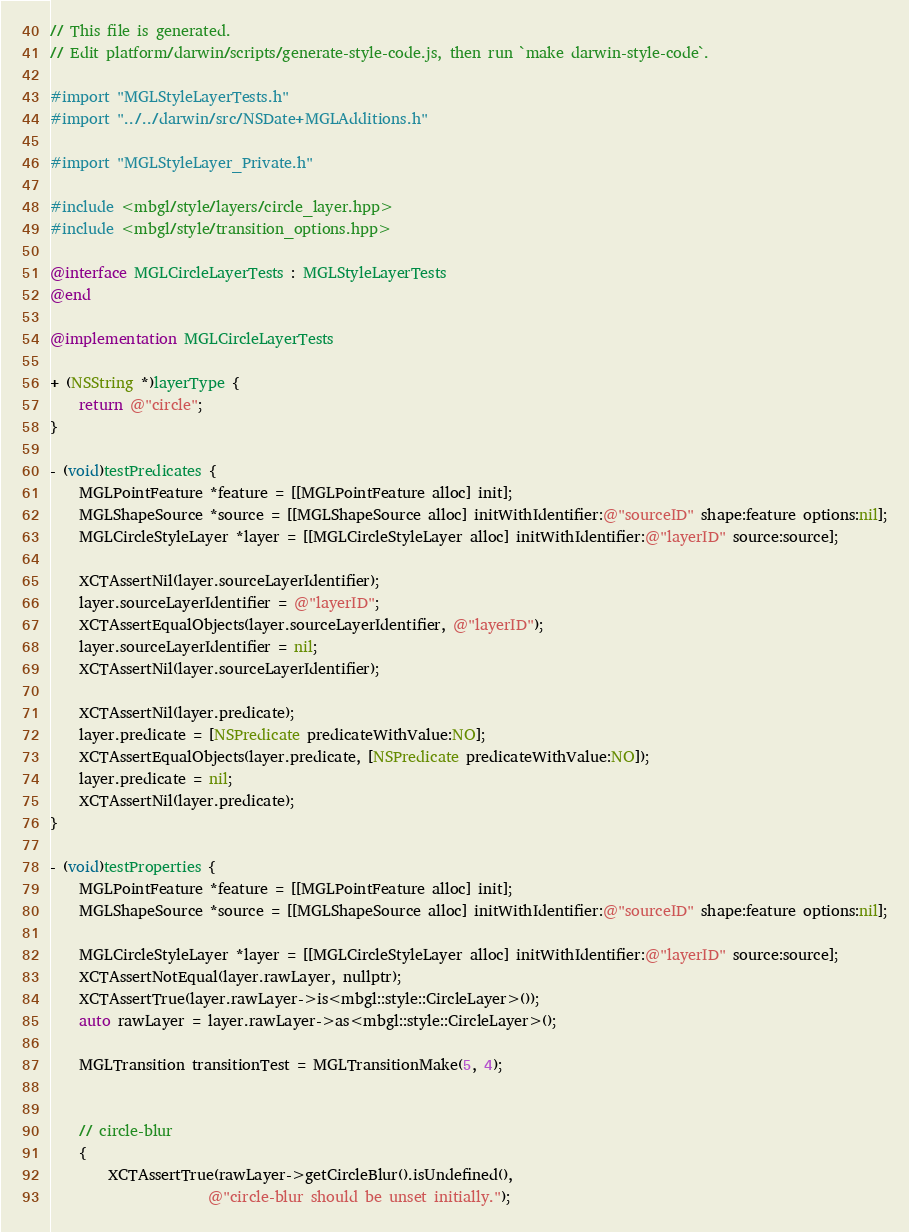<code> <loc_0><loc_0><loc_500><loc_500><_ObjectiveC_>// This file is generated.
// Edit platform/darwin/scripts/generate-style-code.js, then run `make darwin-style-code`.

#import "MGLStyleLayerTests.h"
#import "../../darwin/src/NSDate+MGLAdditions.h"

#import "MGLStyleLayer_Private.h"

#include <mbgl/style/layers/circle_layer.hpp>
#include <mbgl/style/transition_options.hpp>

@interface MGLCircleLayerTests : MGLStyleLayerTests
@end

@implementation MGLCircleLayerTests

+ (NSString *)layerType {
    return @"circle";
}

- (void)testPredicates {
    MGLPointFeature *feature = [[MGLPointFeature alloc] init];
    MGLShapeSource *source = [[MGLShapeSource alloc] initWithIdentifier:@"sourceID" shape:feature options:nil];
    MGLCircleStyleLayer *layer = [[MGLCircleStyleLayer alloc] initWithIdentifier:@"layerID" source:source];

    XCTAssertNil(layer.sourceLayerIdentifier);
    layer.sourceLayerIdentifier = @"layerID";
    XCTAssertEqualObjects(layer.sourceLayerIdentifier, @"layerID");
    layer.sourceLayerIdentifier = nil;
    XCTAssertNil(layer.sourceLayerIdentifier);

    XCTAssertNil(layer.predicate);
    layer.predicate = [NSPredicate predicateWithValue:NO];
    XCTAssertEqualObjects(layer.predicate, [NSPredicate predicateWithValue:NO]);
    layer.predicate = nil;
    XCTAssertNil(layer.predicate);
}

- (void)testProperties {
    MGLPointFeature *feature = [[MGLPointFeature alloc] init];
    MGLShapeSource *source = [[MGLShapeSource alloc] initWithIdentifier:@"sourceID" shape:feature options:nil];

    MGLCircleStyleLayer *layer = [[MGLCircleStyleLayer alloc] initWithIdentifier:@"layerID" source:source];
    XCTAssertNotEqual(layer.rawLayer, nullptr);
    XCTAssertTrue(layer.rawLayer->is<mbgl::style::CircleLayer>());
    auto rawLayer = layer.rawLayer->as<mbgl::style::CircleLayer>();

    MGLTransition transitionTest = MGLTransitionMake(5, 4);


    // circle-blur
    {
        XCTAssertTrue(rawLayer->getCircleBlur().isUndefined(),
                      @"circle-blur should be unset initially.");</code> 